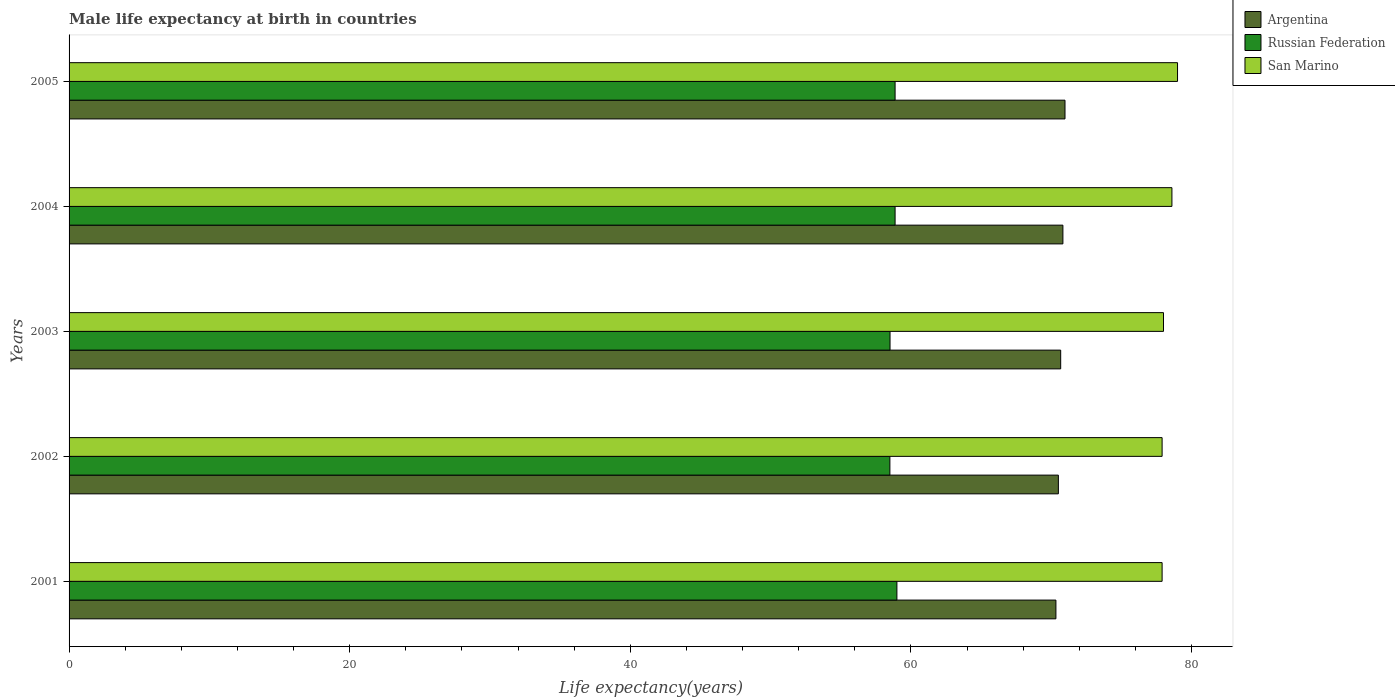How many different coloured bars are there?
Keep it short and to the point. 3. How many groups of bars are there?
Provide a short and direct response. 5. In how many cases, is the number of bars for a given year not equal to the number of legend labels?
Provide a short and direct response. 0. What is the male life expectancy at birth in Argentina in 2004?
Your response must be concise. 70.83. Across all years, what is the maximum male life expectancy at birth in San Marino?
Provide a short and direct response. 79. Across all years, what is the minimum male life expectancy at birth in San Marino?
Offer a terse response. 77.9. In which year was the male life expectancy at birth in Argentina maximum?
Your answer should be compact. 2005. What is the total male life expectancy at birth in Russian Federation in the graph?
Ensure brevity in your answer.  293.75. What is the difference between the male life expectancy at birth in Russian Federation in 2002 and that in 2004?
Offer a terse response. -0.37. What is the difference between the male life expectancy at birth in Argentina in 2004 and the male life expectancy at birth in San Marino in 2005?
Your response must be concise. -8.17. What is the average male life expectancy at birth in San Marino per year?
Ensure brevity in your answer.  78.28. In the year 2003, what is the difference between the male life expectancy at birth in Argentina and male life expectancy at birth in San Marino?
Offer a very short reply. -7.33. In how many years, is the male life expectancy at birth in San Marino greater than 4 years?
Offer a terse response. 5. What is the ratio of the male life expectancy at birth in San Marino in 2003 to that in 2005?
Keep it short and to the point. 0.99. Is the male life expectancy at birth in Russian Federation in 2001 less than that in 2004?
Your response must be concise. No. What is the difference between the highest and the second highest male life expectancy at birth in Argentina?
Offer a very short reply. 0.15. What is the difference between the highest and the lowest male life expectancy at birth in San Marino?
Provide a succinct answer. 1.1. In how many years, is the male life expectancy at birth in Russian Federation greater than the average male life expectancy at birth in Russian Federation taken over all years?
Provide a short and direct response. 3. What does the 3rd bar from the top in 2001 represents?
Your response must be concise. Argentina. What does the 2nd bar from the bottom in 2001 represents?
Your response must be concise. Russian Federation. Is it the case that in every year, the sum of the male life expectancy at birth in Russian Federation and male life expectancy at birth in San Marino is greater than the male life expectancy at birth in Argentina?
Keep it short and to the point. Yes. Are all the bars in the graph horizontal?
Give a very brief answer. Yes. How many years are there in the graph?
Offer a terse response. 5. Are the values on the major ticks of X-axis written in scientific E-notation?
Provide a succinct answer. No. Does the graph contain grids?
Provide a short and direct response. No. Where does the legend appear in the graph?
Keep it short and to the point. Top right. How are the legend labels stacked?
Make the answer very short. Vertical. What is the title of the graph?
Your response must be concise. Male life expectancy at birth in countries. What is the label or title of the X-axis?
Make the answer very short. Life expectancy(years). What is the Life expectancy(years) of Argentina in 2001?
Make the answer very short. 70.33. What is the Life expectancy(years) in San Marino in 2001?
Your answer should be very brief. 77.9. What is the Life expectancy(years) of Argentina in 2002?
Keep it short and to the point. 70.51. What is the Life expectancy(years) of Russian Federation in 2002?
Provide a short and direct response. 58.5. What is the Life expectancy(years) of San Marino in 2002?
Make the answer very short. 77.9. What is the Life expectancy(years) of Argentina in 2003?
Provide a succinct answer. 70.67. What is the Life expectancy(years) in Russian Federation in 2003?
Provide a short and direct response. 58.51. What is the Life expectancy(years) in San Marino in 2003?
Offer a very short reply. 78. What is the Life expectancy(years) in Argentina in 2004?
Your response must be concise. 70.83. What is the Life expectancy(years) in Russian Federation in 2004?
Offer a terse response. 58.87. What is the Life expectancy(years) in San Marino in 2004?
Keep it short and to the point. 78.6. What is the Life expectancy(years) in Argentina in 2005?
Provide a short and direct response. 70.98. What is the Life expectancy(years) of Russian Federation in 2005?
Provide a short and direct response. 58.87. What is the Life expectancy(years) in San Marino in 2005?
Your answer should be very brief. 79. Across all years, what is the maximum Life expectancy(years) in Argentina?
Offer a terse response. 70.98. Across all years, what is the maximum Life expectancy(years) in San Marino?
Your answer should be compact. 79. Across all years, what is the minimum Life expectancy(years) in Argentina?
Ensure brevity in your answer.  70.33. Across all years, what is the minimum Life expectancy(years) of Russian Federation?
Your answer should be very brief. 58.5. Across all years, what is the minimum Life expectancy(years) in San Marino?
Your answer should be very brief. 77.9. What is the total Life expectancy(years) of Argentina in the graph?
Provide a succinct answer. 353.32. What is the total Life expectancy(years) of Russian Federation in the graph?
Offer a terse response. 293.75. What is the total Life expectancy(years) of San Marino in the graph?
Make the answer very short. 391.4. What is the difference between the Life expectancy(years) in Argentina in 2001 and that in 2002?
Your answer should be very brief. -0.17. What is the difference between the Life expectancy(years) in San Marino in 2001 and that in 2002?
Provide a succinct answer. 0. What is the difference between the Life expectancy(years) of Argentina in 2001 and that in 2003?
Offer a terse response. -0.34. What is the difference between the Life expectancy(years) in Russian Federation in 2001 and that in 2003?
Your response must be concise. 0.49. What is the difference between the Life expectancy(years) of Argentina in 2001 and that in 2004?
Give a very brief answer. -0.5. What is the difference between the Life expectancy(years) of Russian Federation in 2001 and that in 2004?
Ensure brevity in your answer.  0.13. What is the difference between the Life expectancy(years) in San Marino in 2001 and that in 2004?
Your answer should be compact. -0.7. What is the difference between the Life expectancy(years) of Argentina in 2001 and that in 2005?
Keep it short and to the point. -0.65. What is the difference between the Life expectancy(years) of Russian Federation in 2001 and that in 2005?
Your answer should be compact. 0.13. What is the difference between the Life expectancy(years) of San Marino in 2001 and that in 2005?
Ensure brevity in your answer.  -1.1. What is the difference between the Life expectancy(years) in Argentina in 2002 and that in 2003?
Your response must be concise. -0.17. What is the difference between the Life expectancy(years) of Russian Federation in 2002 and that in 2003?
Your answer should be compact. -0.01. What is the difference between the Life expectancy(years) of Argentina in 2002 and that in 2004?
Make the answer very short. -0.32. What is the difference between the Life expectancy(years) in Russian Federation in 2002 and that in 2004?
Ensure brevity in your answer.  -0.37. What is the difference between the Life expectancy(years) of Argentina in 2002 and that in 2005?
Ensure brevity in your answer.  -0.47. What is the difference between the Life expectancy(years) in Russian Federation in 2002 and that in 2005?
Make the answer very short. -0.37. What is the difference between the Life expectancy(years) in San Marino in 2002 and that in 2005?
Make the answer very short. -1.1. What is the difference between the Life expectancy(years) of Argentina in 2003 and that in 2004?
Offer a very short reply. -0.16. What is the difference between the Life expectancy(years) in Russian Federation in 2003 and that in 2004?
Provide a short and direct response. -0.36. What is the difference between the Life expectancy(years) in San Marino in 2003 and that in 2004?
Make the answer very short. -0.6. What is the difference between the Life expectancy(years) of Argentina in 2003 and that in 2005?
Offer a very short reply. -0.31. What is the difference between the Life expectancy(years) in Russian Federation in 2003 and that in 2005?
Your response must be concise. -0.36. What is the difference between the Life expectancy(years) in San Marino in 2003 and that in 2005?
Your answer should be compact. -1. What is the difference between the Life expectancy(years) of Argentina in 2004 and that in 2005?
Provide a short and direct response. -0.15. What is the difference between the Life expectancy(years) of San Marino in 2004 and that in 2005?
Keep it short and to the point. -0.4. What is the difference between the Life expectancy(years) of Argentina in 2001 and the Life expectancy(years) of Russian Federation in 2002?
Make the answer very short. 11.83. What is the difference between the Life expectancy(years) of Argentina in 2001 and the Life expectancy(years) of San Marino in 2002?
Keep it short and to the point. -7.57. What is the difference between the Life expectancy(years) in Russian Federation in 2001 and the Life expectancy(years) in San Marino in 2002?
Your answer should be compact. -18.9. What is the difference between the Life expectancy(years) in Argentina in 2001 and the Life expectancy(years) in Russian Federation in 2003?
Provide a short and direct response. 11.82. What is the difference between the Life expectancy(years) in Argentina in 2001 and the Life expectancy(years) in San Marino in 2003?
Provide a succinct answer. -7.67. What is the difference between the Life expectancy(years) of Russian Federation in 2001 and the Life expectancy(years) of San Marino in 2003?
Give a very brief answer. -19. What is the difference between the Life expectancy(years) in Argentina in 2001 and the Life expectancy(years) in Russian Federation in 2004?
Keep it short and to the point. 11.46. What is the difference between the Life expectancy(years) of Argentina in 2001 and the Life expectancy(years) of San Marino in 2004?
Give a very brief answer. -8.27. What is the difference between the Life expectancy(years) in Russian Federation in 2001 and the Life expectancy(years) in San Marino in 2004?
Make the answer very short. -19.6. What is the difference between the Life expectancy(years) of Argentina in 2001 and the Life expectancy(years) of Russian Federation in 2005?
Your response must be concise. 11.46. What is the difference between the Life expectancy(years) in Argentina in 2001 and the Life expectancy(years) in San Marino in 2005?
Make the answer very short. -8.67. What is the difference between the Life expectancy(years) of Russian Federation in 2001 and the Life expectancy(years) of San Marino in 2005?
Offer a terse response. -20. What is the difference between the Life expectancy(years) of Argentina in 2002 and the Life expectancy(years) of Russian Federation in 2003?
Offer a terse response. 12. What is the difference between the Life expectancy(years) of Argentina in 2002 and the Life expectancy(years) of San Marino in 2003?
Your answer should be compact. -7.49. What is the difference between the Life expectancy(years) of Russian Federation in 2002 and the Life expectancy(years) of San Marino in 2003?
Offer a very short reply. -19.5. What is the difference between the Life expectancy(years) of Argentina in 2002 and the Life expectancy(years) of Russian Federation in 2004?
Offer a very short reply. 11.64. What is the difference between the Life expectancy(years) in Argentina in 2002 and the Life expectancy(years) in San Marino in 2004?
Provide a short and direct response. -8.09. What is the difference between the Life expectancy(years) in Russian Federation in 2002 and the Life expectancy(years) in San Marino in 2004?
Ensure brevity in your answer.  -20.1. What is the difference between the Life expectancy(years) of Argentina in 2002 and the Life expectancy(years) of Russian Federation in 2005?
Make the answer very short. 11.64. What is the difference between the Life expectancy(years) of Argentina in 2002 and the Life expectancy(years) of San Marino in 2005?
Give a very brief answer. -8.49. What is the difference between the Life expectancy(years) of Russian Federation in 2002 and the Life expectancy(years) of San Marino in 2005?
Your answer should be very brief. -20.5. What is the difference between the Life expectancy(years) of Argentina in 2003 and the Life expectancy(years) of Russian Federation in 2004?
Your answer should be very brief. 11.8. What is the difference between the Life expectancy(years) in Argentina in 2003 and the Life expectancy(years) in San Marino in 2004?
Offer a terse response. -7.93. What is the difference between the Life expectancy(years) in Russian Federation in 2003 and the Life expectancy(years) in San Marino in 2004?
Your answer should be compact. -20.09. What is the difference between the Life expectancy(years) in Argentina in 2003 and the Life expectancy(years) in Russian Federation in 2005?
Provide a succinct answer. 11.8. What is the difference between the Life expectancy(years) of Argentina in 2003 and the Life expectancy(years) of San Marino in 2005?
Make the answer very short. -8.33. What is the difference between the Life expectancy(years) of Russian Federation in 2003 and the Life expectancy(years) of San Marino in 2005?
Offer a terse response. -20.49. What is the difference between the Life expectancy(years) of Argentina in 2004 and the Life expectancy(years) of Russian Federation in 2005?
Provide a short and direct response. 11.96. What is the difference between the Life expectancy(years) of Argentina in 2004 and the Life expectancy(years) of San Marino in 2005?
Your answer should be compact. -8.17. What is the difference between the Life expectancy(years) in Russian Federation in 2004 and the Life expectancy(years) in San Marino in 2005?
Keep it short and to the point. -20.13. What is the average Life expectancy(years) in Argentina per year?
Make the answer very short. 70.66. What is the average Life expectancy(years) of Russian Federation per year?
Provide a short and direct response. 58.75. What is the average Life expectancy(years) of San Marino per year?
Provide a succinct answer. 78.28. In the year 2001, what is the difference between the Life expectancy(years) in Argentina and Life expectancy(years) in Russian Federation?
Your answer should be very brief. 11.33. In the year 2001, what is the difference between the Life expectancy(years) in Argentina and Life expectancy(years) in San Marino?
Offer a very short reply. -7.57. In the year 2001, what is the difference between the Life expectancy(years) of Russian Federation and Life expectancy(years) of San Marino?
Your answer should be very brief. -18.9. In the year 2002, what is the difference between the Life expectancy(years) in Argentina and Life expectancy(years) in Russian Federation?
Offer a very short reply. 12.01. In the year 2002, what is the difference between the Life expectancy(years) in Argentina and Life expectancy(years) in San Marino?
Ensure brevity in your answer.  -7.39. In the year 2002, what is the difference between the Life expectancy(years) of Russian Federation and Life expectancy(years) of San Marino?
Your response must be concise. -19.4. In the year 2003, what is the difference between the Life expectancy(years) in Argentina and Life expectancy(years) in Russian Federation?
Keep it short and to the point. 12.16. In the year 2003, what is the difference between the Life expectancy(years) in Argentina and Life expectancy(years) in San Marino?
Make the answer very short. -7.33. In the year 2003, what is the difference between the Life expectancy(years) in Russian Federation and Life expectancy(years) in San Marino?
Ensure brevity in your answer.  -19.49. In the year 2004, what is the difference between the Life expectancy(years) of Argentina and Life expectancy(years) of Russian Federation?
Give a very brief answer. 11.96. In the year 2004, what is the difference between the Life expectancy(years) in Argentina and Life expectancy(years) in San Marino?
Offer a very short reply. -7.77. In the year 2004, what is the difference between the Life expectancy(years) in Russian Federation and Life expectancy(years) in San Marino?
Your response must be concise. -19.73. In the year 2005, what is the difference between the Life expectancy(years) in Argentina and Life expectancy(years) in Russian Federation?
Keep it short and to the point. 12.11. In the year 2005, what is the difference between the Life expectancy(years) of Argentina and Life expectancy(years) of San Marino?
Ensure brevity in your answer.  -8.02. In the year 2005, what is the difference between the Life expectancy(years) in Russian Federation and Life expectancy(years) in San Marino?
Offer a very short reply. -20.13. What is the ratio of the Life expectancy(years) in Russian Federation in 2001 to that in 2002?
Provide a succinct answer. 1.01. What is the ratio of the Life expectancy(years) of Russian Federation in 2001 to that in 2003?
Ensure brevity in your answer.  1.01. What is the ratio of the Life expectancy(years) of San Marino in 2001 to that in 2003?
Give a very brief answer. 1. What is the ratio of the Life expectancy(years) of Argentina in 2001 to that in 2004?
Make the answer very short. 0.99. What is the ratio of the Life expectancy(years) of Russian Federation in 2001 to that in 2004?
Your answer should be very brief. 1. What is the ratio of the Life expectancy(years) in Argentina in 2001 to that in 2005?
Provide a short and direct response. 0.99. What is the ratio of the Life expectancy(years) of Russian Federation in 2001 to that in 2005?
Provide a short and direct response. 1. What is the ratio of the Life expectancy(years) of San Marino in 2001 to that in 2005?
Offer a terse response. 0.99. What is the ratio of the Life expectancy(years) of Argentina in 2002 to that in 2003?
Your answer should be very brief. 1. What is the ratio of the Life expectancy(years) in Russian Federation in 2002 to that in 2003?
Ensure brevity in your answer.  1. What is the ratio of the Life expectancy(years) of Argentina in 2002 to that in 2004?
Keep it short and to the point. 1. What is the ratio of the Life expectancy(years) of San Marino in 2002 to that in 2004?
Offer a very short reply. 0.99. What is the ratio of the Life expectancy(years) in Argentina in 2002 to that in 2005?
Offer a very short reply. 0.99. What is the ratio of the Life expectancy(years) of San Marino in 2002 to that in 2005?
Keep it short and to the point. 0.99. What is the ratio of the Life expectancy(years) in Argentina in 2003 to that in 2004?
Your response must be concise. 1. What is the ratio of the Life expectancy(years) of Russian Federation in 2003 to that in 2004?
Give a very brief answer. 0.99. What is the ratio of the Life expectancy(years) in Argentina in 2003 to that in 2005?
Your answer should be compact. 1. What is the ratio of the Life expectancy(years) of Russian Federation in 2003 to that in 2005?
Ensure brevity in your answer.  0.99. What is the ratio of the Life expectancy(years) in San Marino in 2003 to that in 2005?
Give a very brief answer. 0.99. What is the ratio of the Life expectancy(years) in Argentina in 2004 to that in 2005?
Offer a very short reply. 1. What is the ratio of the Life expectancy(years) in San Marino in 2004 to that in 2005?
Make the answer very short. 0.99. What is the difference between the highest and the second highest Life expectancy(years) of Russian Federation?
Offer a very short reply. 0.13. What is the difference between the highest and the lowest Life expectancy(years) in Argentina?
Make the answer very short. 0.65. 